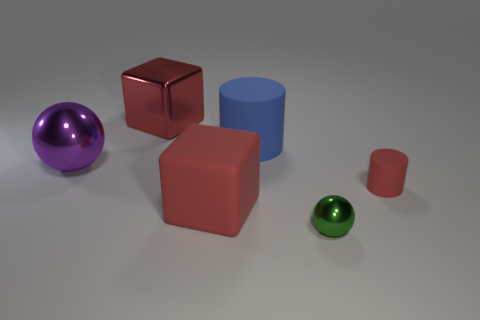Can you create a story about the green sphere's relationship with the other objects? In an imaginary world, the green sphere could be considered the 'emerald wanderer' who has just rolled into a town of geometric citizens. The red cube is the mayor, the purple sphere - the local artist, the blue cylinder - the town’s storyteller, and the smaller red cylinder is the young apprentice eager to learn from the green visitor. 